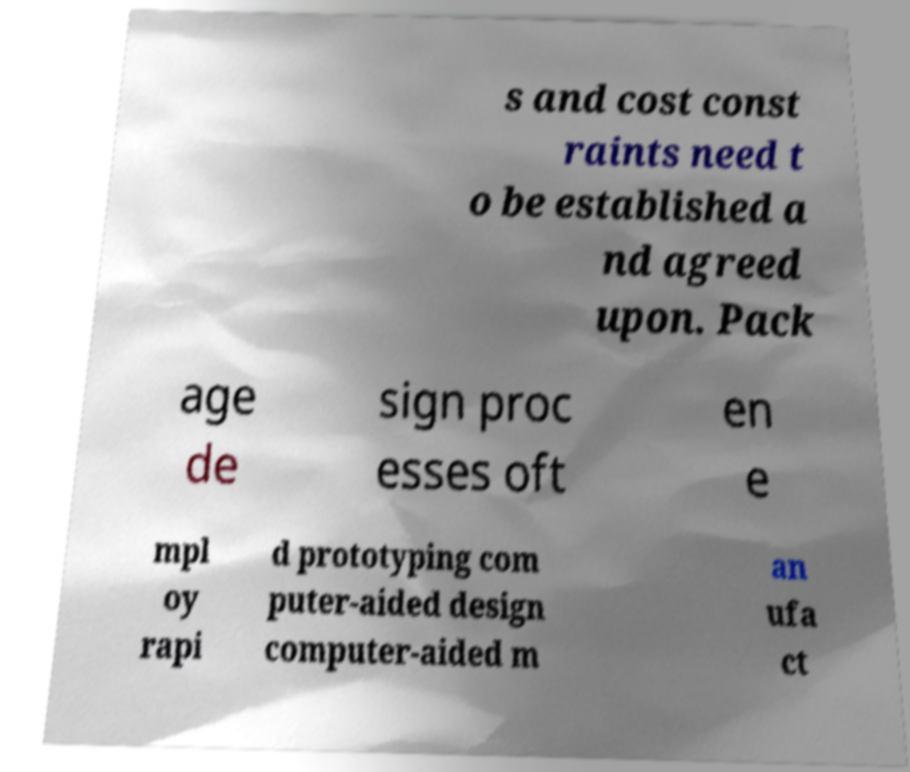Please read and relay the text visible in this image. What does it say? s and cost const raints need t o be established a nd agreed upon. Pack age de sign proc esses oft en e mpl oy rapi d prototyping com puter-aided design computer-aided m an ufa ct 